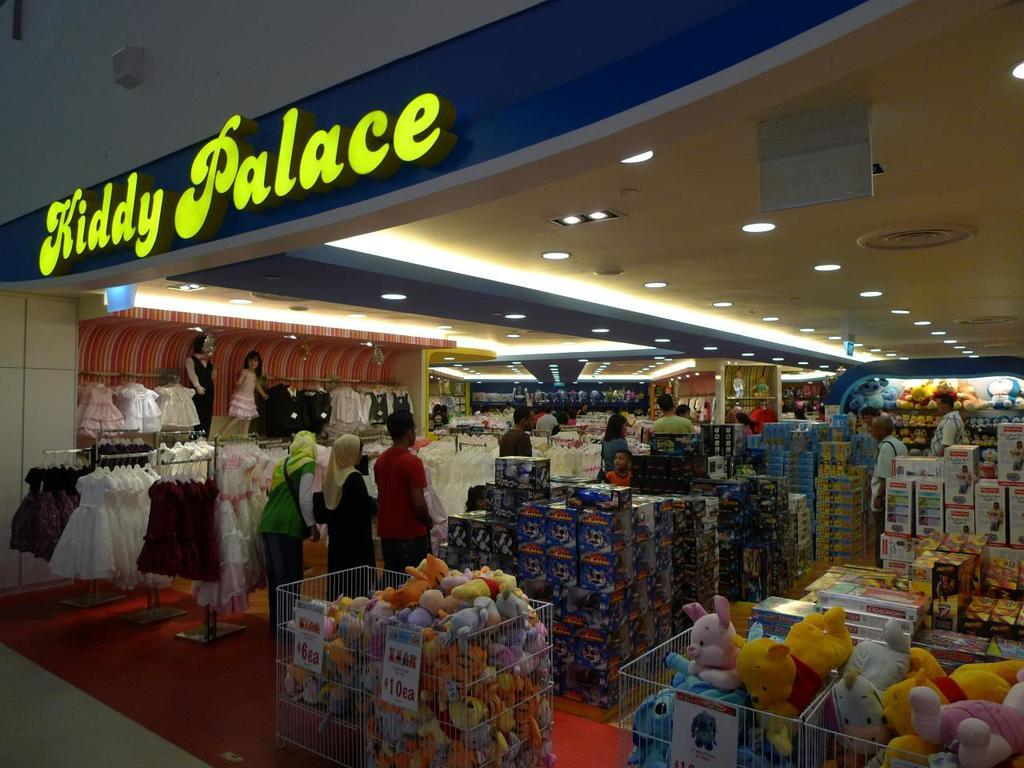<image>
Give a short and clear explanation of the subsequent image. A store with clothing and toys that has a sign out front called Kiddy Palace. 